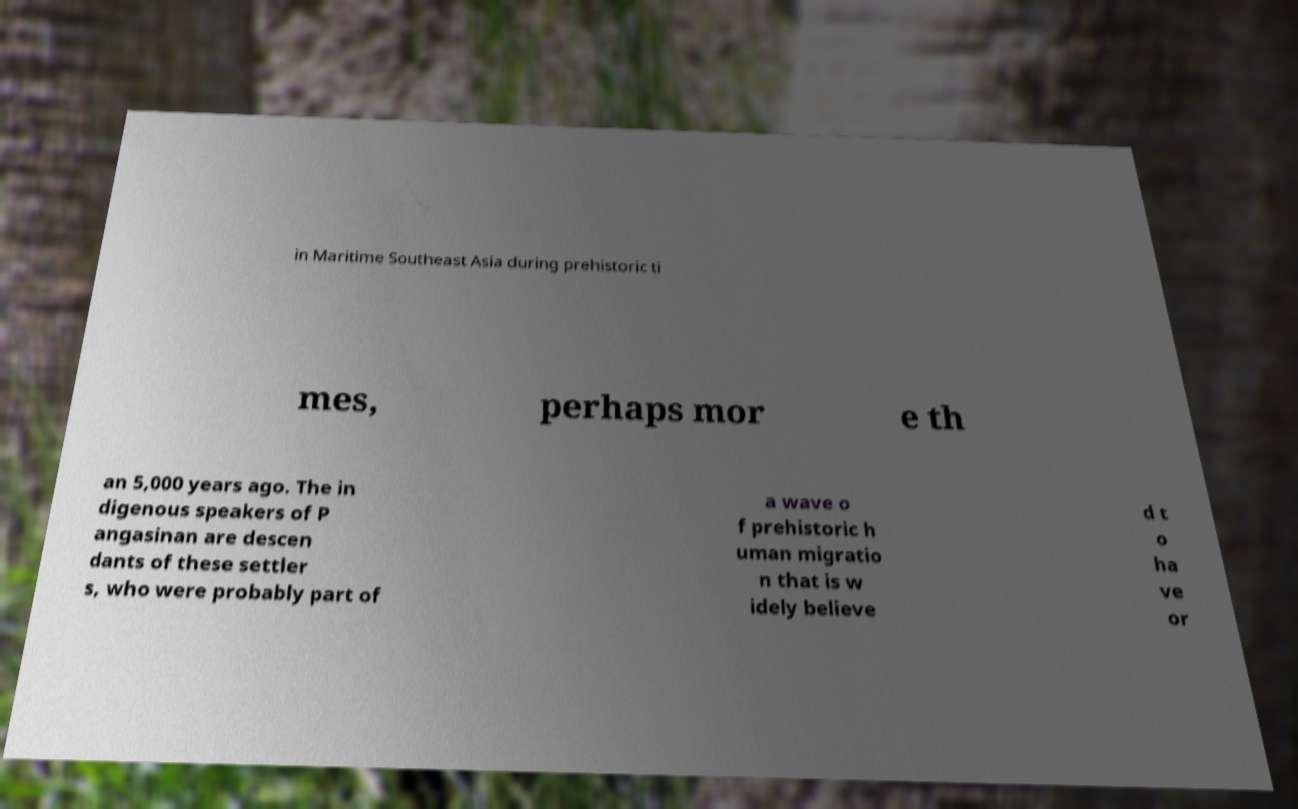I need the written content from this picture converted into text. Can you do that? in Maritime Southeast Asia during prehistoric ti mes, perhaps mor e th an 5,000 years ago. The in digenous speakers of P angasinan are descen dants of these settler s, who were probably part of a wave o f prehistoric h uman migratio n that is w idely believe d t o ha ve or 